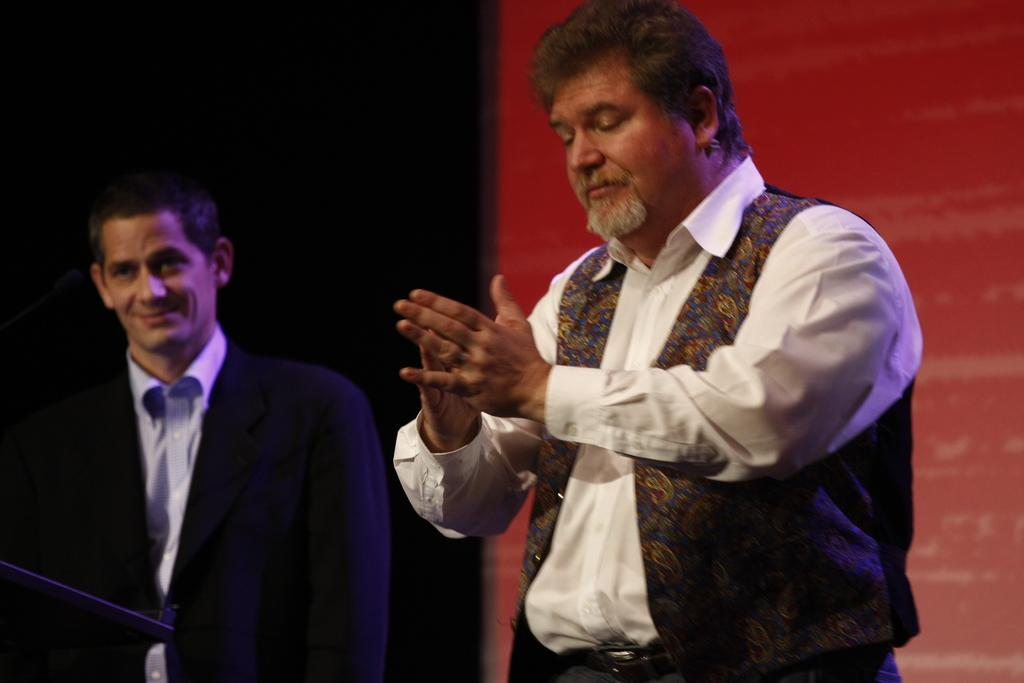How many people are present in the image? There are two men standing in the image. What can be seen in the background of the image? There is a wall in the background of the image. What type of leaf is being used by the writer in the image? There is no writer or leaf present in the image; it features two men standing in front of a wall. What is causing the men to laugh in the image? There is no indication that the men are laughing in the image. 